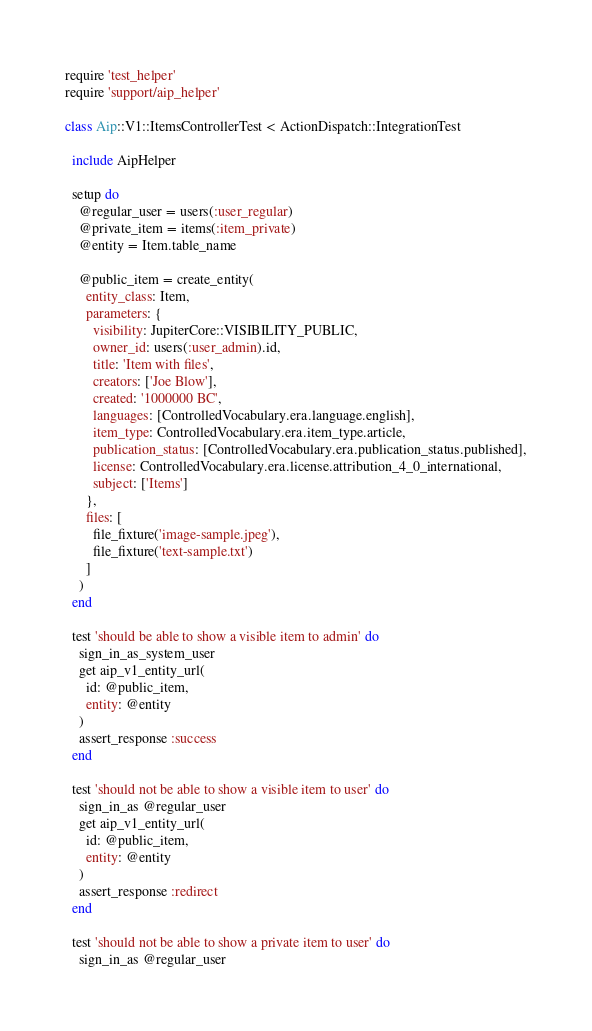<code> <loc_0><loc_0><loc_500><loc_500><_Ruby_>require 'test_helper'
require 'support/aip_helper'

class Aip::V1::ItemsControllerTest < ActionDispatch::IntegrationTest

  include AipHelper

  setup do
    @regular_user = users(:user_regular)
    @private_item = items(:item_private)
    @entity = Item.table_name

    @public_item = create_entity(
      entity_class: Item,
      parameters: {
        visibility: JupiterCore::VISIBILITY_PUBLIC,
        owner_id: users(:user_admin).id,
        title: 'Item with files',
        creators: ['Joe Blow'],
        created: '1000000 BC',
        languages: [ControlledVocabulary.era.language.english],
        item_type: ControlledVocabulary.era.item_type.article,
        publication_status: [ControlledVocabulary.era.publication_status.published],
        license: ControlledVocabulary.era.license.attribution_4_0_international,
        subject: ['Items']
      },
      files: [
        file_fixture('image-sample.jpeg'),
        file_fixture('text-sample.txt')
      ]
    )
  end

  test 'should be able to show a visible item to admin' do
    sign_in_as_system_user
    get aip_v1_entity_url(
      id: @public_item,
      entity: @entity
    )
    assert_response :success
  end

  test 'should not be able to show a visible item to user' do
    sign_in_as @regular_user
    get aip_v1_entity_url(
      id: @public_item,
      entity: @entity
    )
    assert_response :redirect
  end

  test 'should not be able to show a private item to user' do
    sign_in_as @regular_user</code> 